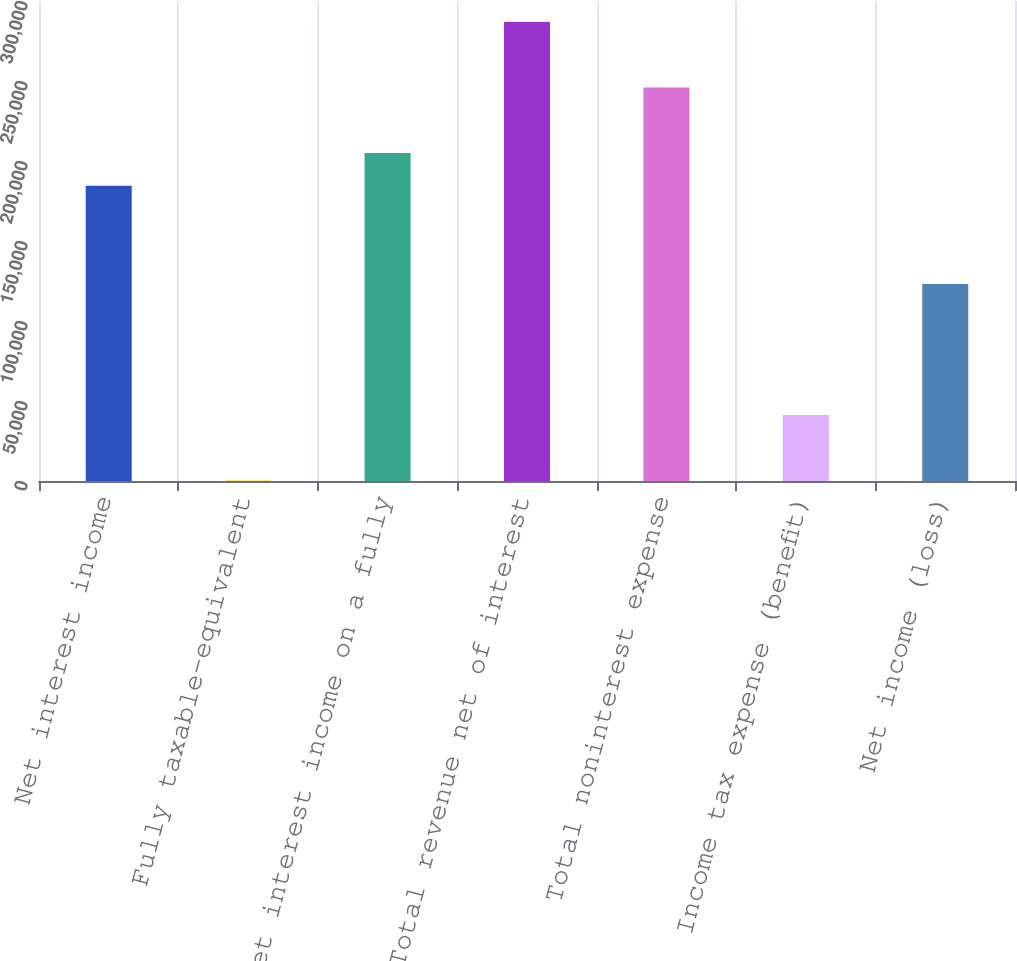<chart> <loc_0><loc_0><loc_500><loc_500><bar_chart><fcel>Net interest income<fcel>Fully taxable-equivalent<fcel>Net interest income on a fully<fcel>Total revenue net of interest<fcel>Total noninterest expense<fcel>Income tax expense (benefit)<fcel>Net income (loss)<nl><fcel>184460<fcel>249<fcel>204928<fcel>286800<fcel>245864<fcel>41184.8<fcel>123056<nl></chart> 